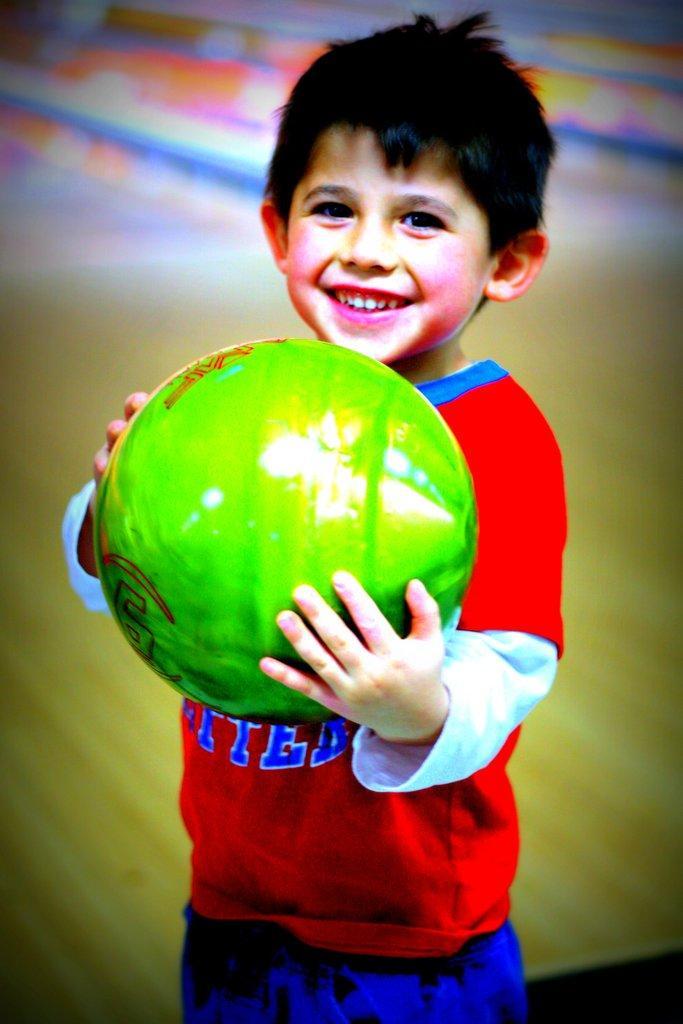How would you summarize this image in a sentence or two? In this image I can see a child wearing red t shirt and blue pant is standing ad holding a green colored ball in his hand and I can see the blurry background. 